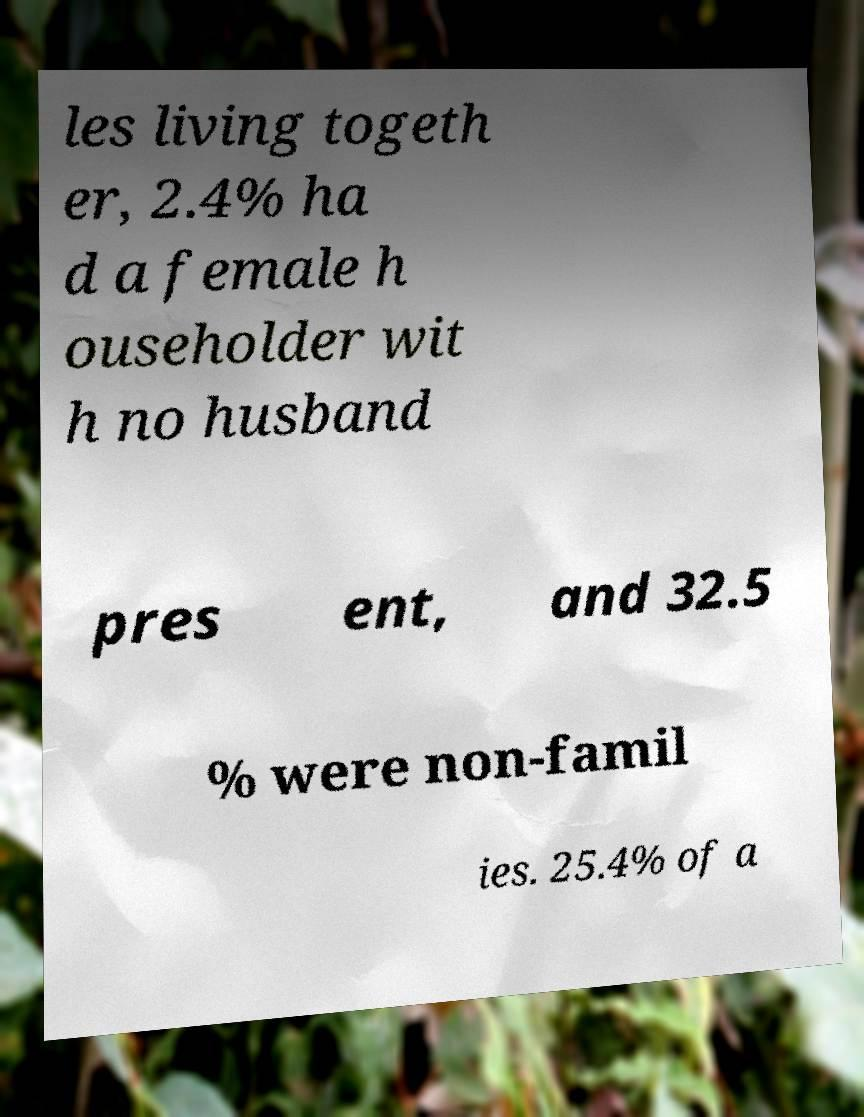For documentation purposes, I need the text within this image transcribed. Could you provide that? les living togeth er, 2.4% ha d a female h ouseholder wit h no husband pres ent, and 32.5 % were non-famil ies. 25.4% of a 